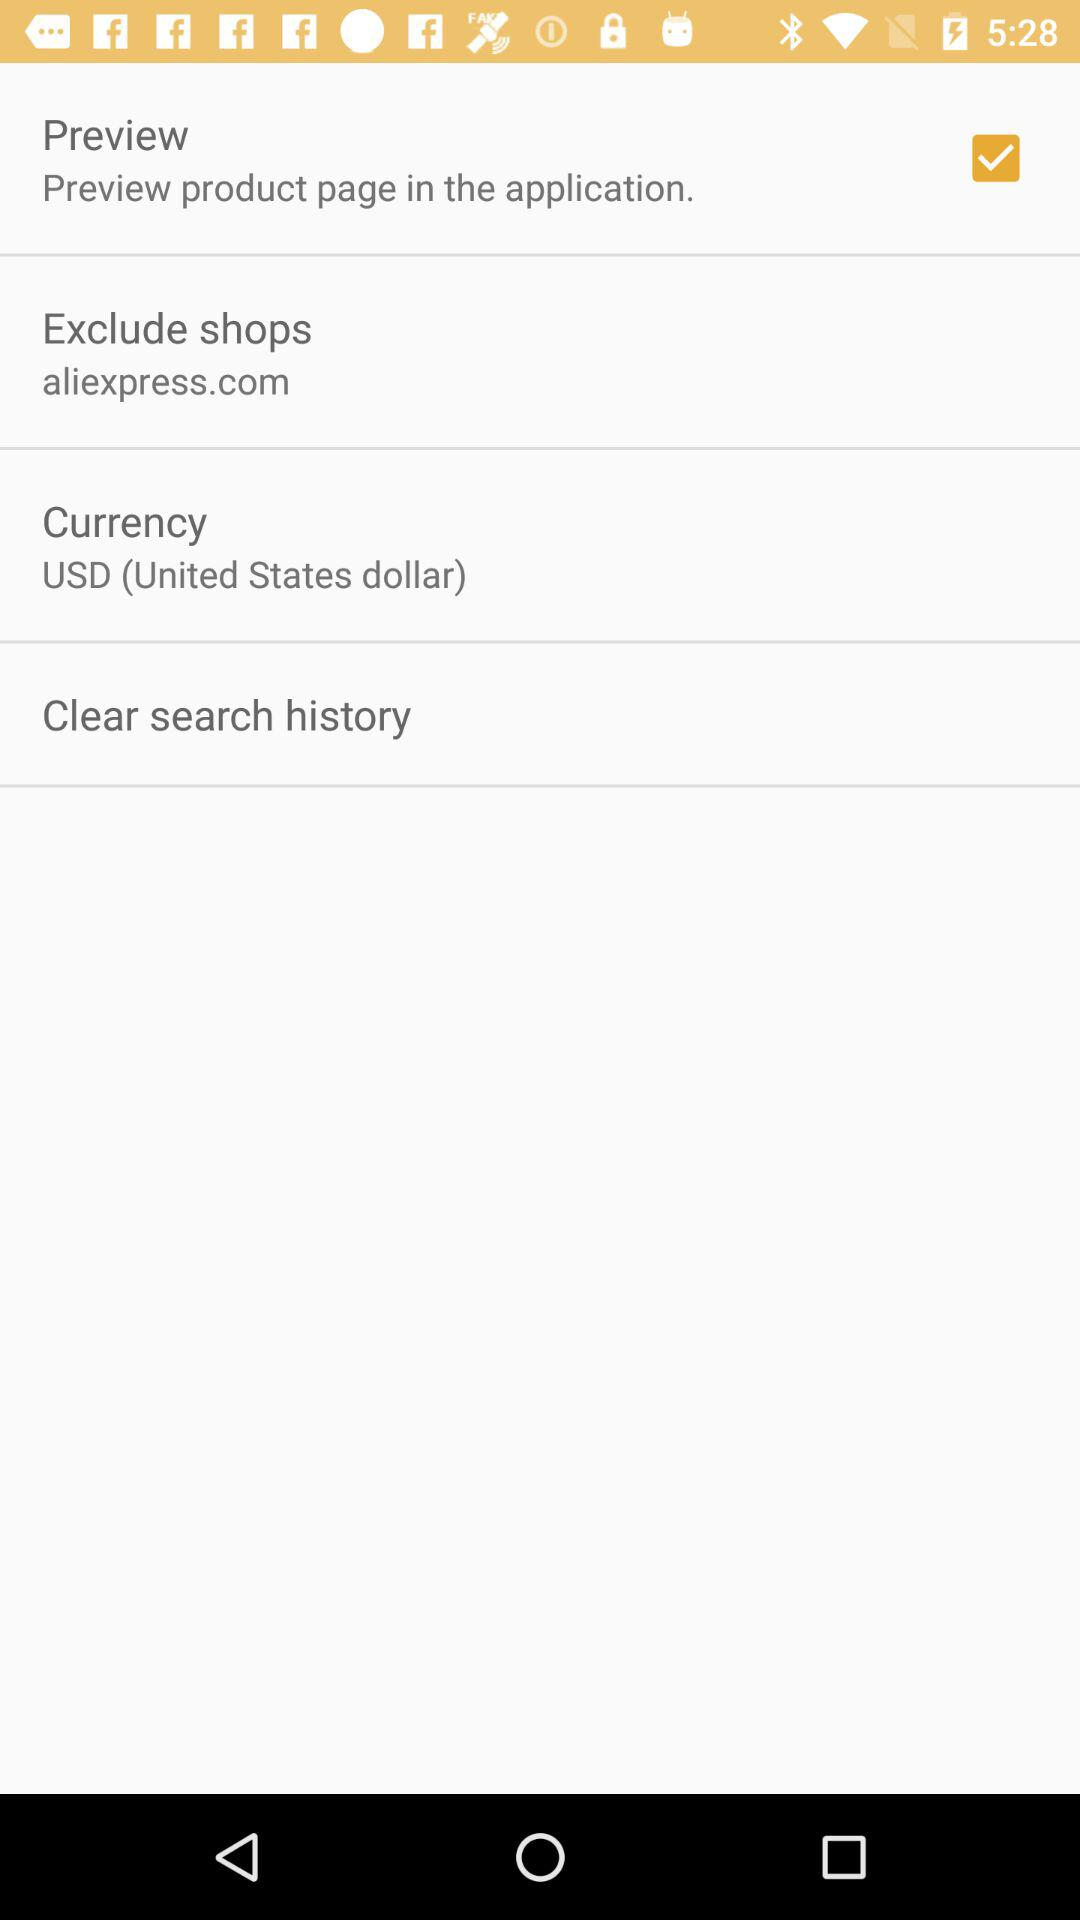What is the selected option? The selected option is "Preview". 